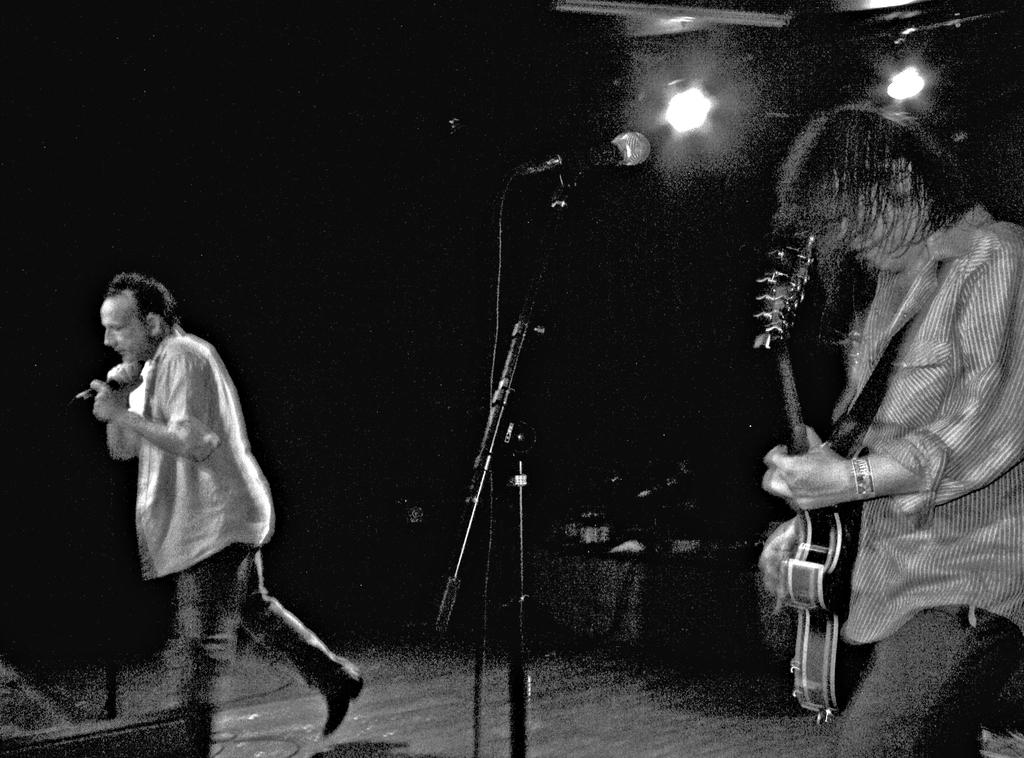What is the man in the image doing? There is a man walking in the image. What is the man holding in his hand? The man is holding a microphone in his hand. Can you describe the second man in the image? The second man is playing a guitar. Is there another microphone in the image? Yes, there is a microphone in front of the second man. What type of metal is used to make the stove in the image? There is no stove present in the image. What is the opinion of the first man about the guitar player? The image does not provide any information about the opinions of the first man or any other person. 